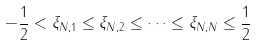Convert formula to latex. <formula><loc_0><loc_0><loc_500><loc_500>- \frac { 1 } { 2 } < \xi _ { N , 1 } \leq \xi _ { N , 2 } \leq \dots \leq \xi _ { N , N } \leq \frac { 1 } { 2 }</formula> 